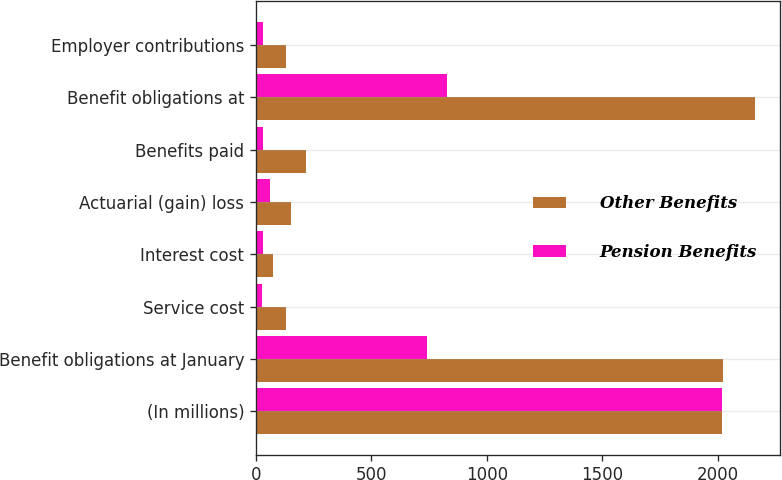Convert chart to OTSL. <chart><loc_0><loc_0><loc_500><loc_500><stacked_bar_chart><ecel><fcel>(In millions)<fcel>Benefit obligations at January<fcel>Service cost<fcel>Interest cost<fcel>Actuarial (gain) loss<fcel>Benefits paid<fcel>Benefit obligations at<fcel>Employer contributions<nl><fcel>Other Benefits<fcel>2017<fcel>2024<fcel>132<fcel>75<fcel>150<fcel>217<fcel>2164<fcel>128<nl><fcel>Pension Benefits<fcel>2017<fcel>740<fcel>25<fcel>30<fcel>61<fcel>30<fcel>826<fcel>30<nl></chart> 